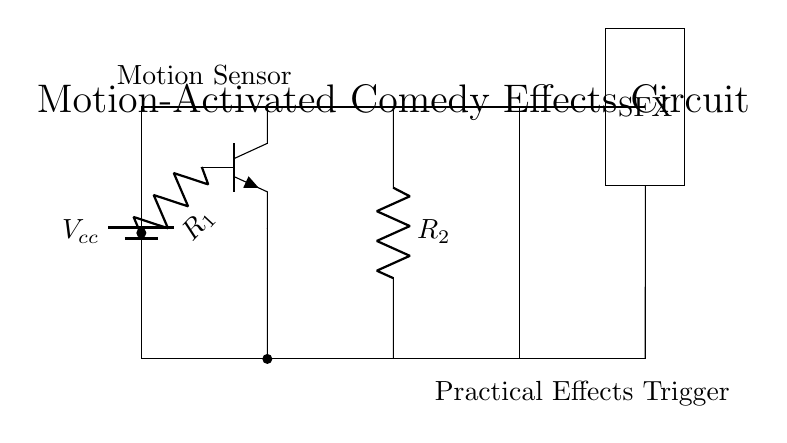What type of sensor is used in this circuit? The circuit diagram shows a motion sensor as indicated by the label next to the component in the diagram. The specific labeling and design indicate its purpose as a motion detector.
Answer: Motion sensor What does R1 represent in the circuit? R1 is a resistor, as indicated by the symbol and the label (R1) in the circuit diagram. It is connected to the base of the motion sensor and defines part of the biasing circuit.
Answer: Resistor How many resistors are present in this circuit? The circuit diagram has two resistors, labeled R1 and R2, which are visually identified in the layout.
Answer: Two What is the function of the relay in this circuit? The relay acts as a switch that gets triggered by the motion sensor output to engage the practical effects component. It connects the motion sensor to the SFX unit.
Answer: Switch What component triggers the special effects? The special effects are triggered by the output of the relay, which is illustrated in the diagram where the relay connects to the special effects block labeled SFX.
Answer: Relay Which connections provide power to the motion sensor? The motion sensor is powered through the connection from the battery (Vcc) to the top of the motion sensor (collector), allowing it to function.
Answer: Battery to sensor What could be the purpose of the special effects unit labeled SFX? The SFX unit is responsible for executing the practical effects, such as a sound or visual effect, whenever triggered by the motion sensor via the relay connection.
Answer: Practical effects 